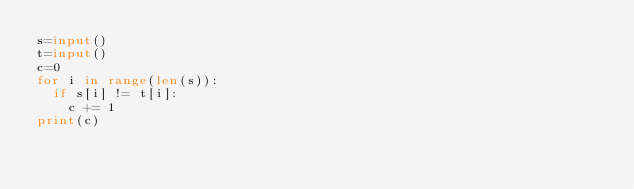Convert code to text. <code><loc_0><loc_0><loc_500><loc_500><_Python_>s=input()
t=input()
c=0
for i in range(len(s)):
  if s[i] != t[i]:
    c += 1
print(c)</code> 